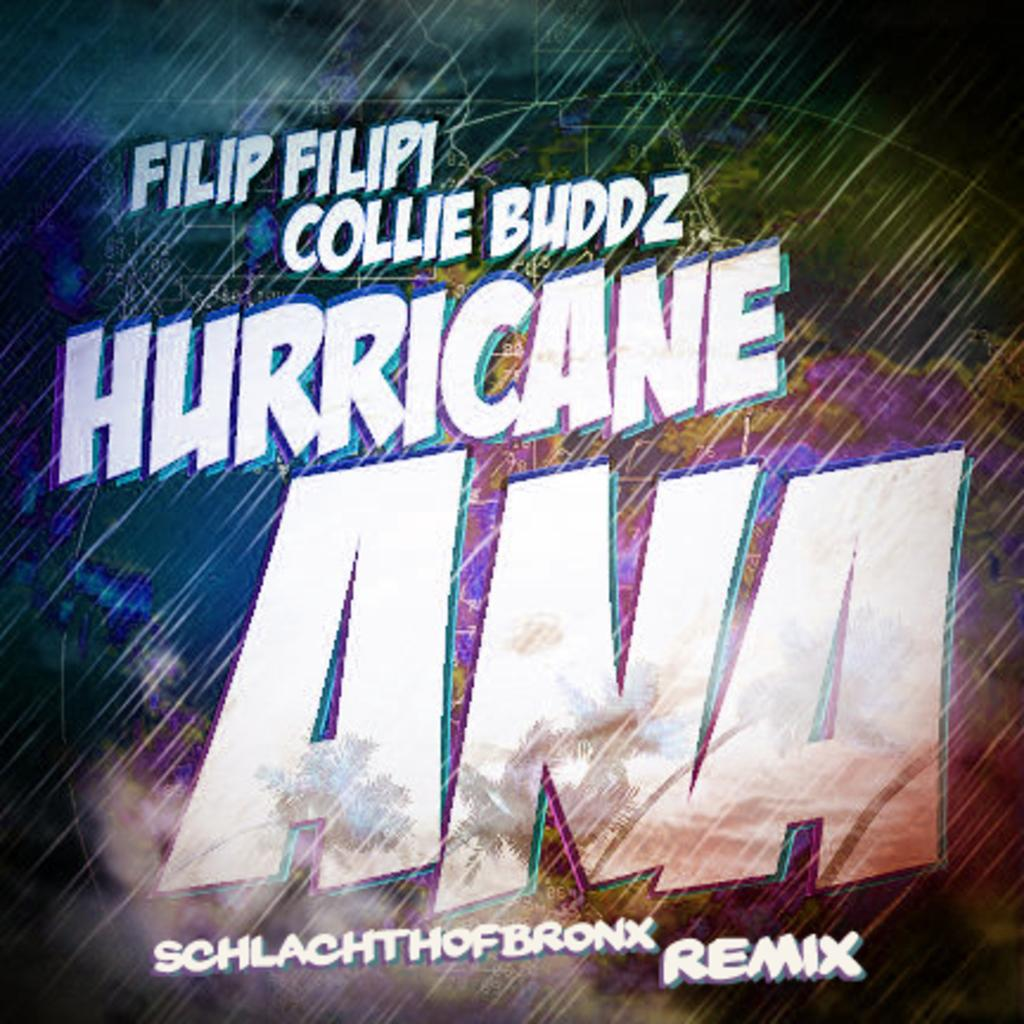<image>
Describe the image concisely. A picture of album titled Hurricane Ana remix is shown 